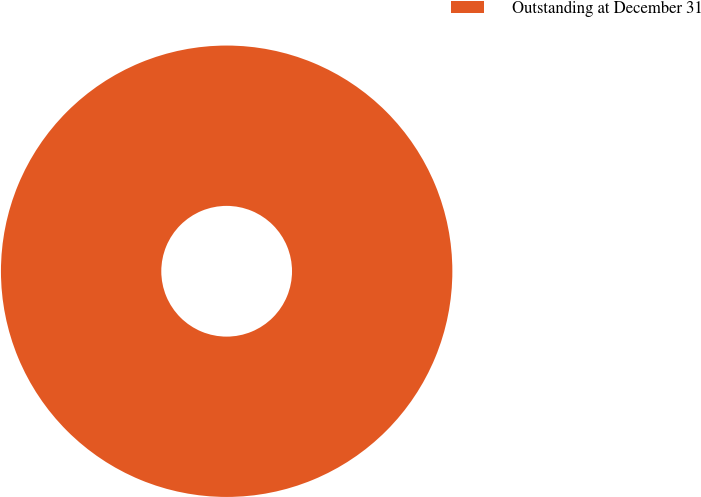Convert chart to OTSL. <chart><loc_0><loc_0><loc_500><loc_500><pie_chart><fcel>Outstanding at December 31<nl><fcel>100.0%<nl></chart> 